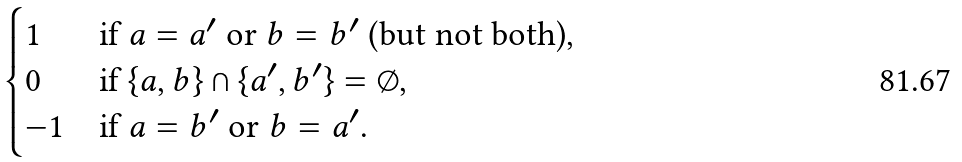Convert formula to latex. <formula><loc_0><loc_0><loc_500><loc_500>\begin{cases} 1 & \text {if $a=a^{\prime}$ or $b=b^{\prime}$ (but not both),} \\ 0 & \text {if $\{a,b\}\cap\{a^{\prime},b^{\prime}\}=\emptyset$,} \\ - 1 & \text {if $a=b^{\prime}$ or $b=a^{\prime}$.} \end{cases}</formula> 